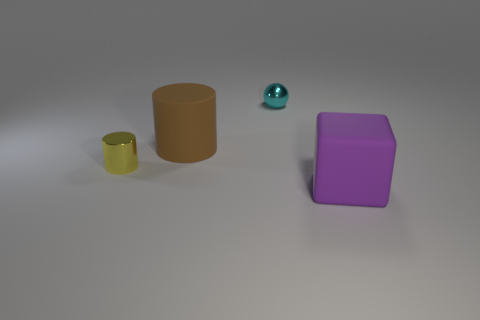Add 2 balls. How many objects exist? 6 Subtract all yellow cylinders. How many cylinders are left? 1 Subtract all balls. How many objects are left? 3 Subtract 1 spheres. How many spheres are left? 0 Subtract all cyan spheres. How many red cylinders are left? 0 Subtract all large gray things. Subtract all rubber cylinders. How many objects are left? 3 Add 3 big brown cylinders. How many big brown cylinders are left? 4 Add 2 tiny purple metal spheres. How many tiny purple metal spheres exist? 2 Subtract 0 purple spheres. How many objects are left? 4 Subtract all yellow cubes. Subtract all blue balls. How many cubes are left? 1 